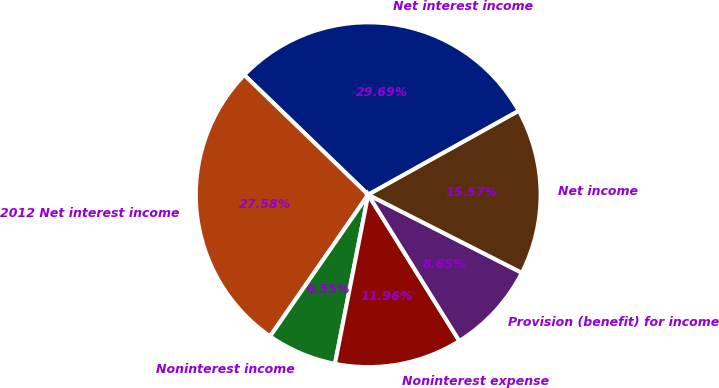Convert chart. <chart><loc_0><loc_0><loc_500><loc_500><pie_chart><fcel>Net interest income<fcel>2012 Net interest income<fcel>Noninterest income<fcel>Noninterest expense<fcel>Provision (benefit) for income<fcel>Net income<nl><fcel>29.69%<fcel>27.58%<fcel>6.55%<fcel>11.96%<fcel>8.65%<fcel>15.57%<nl></chart> 